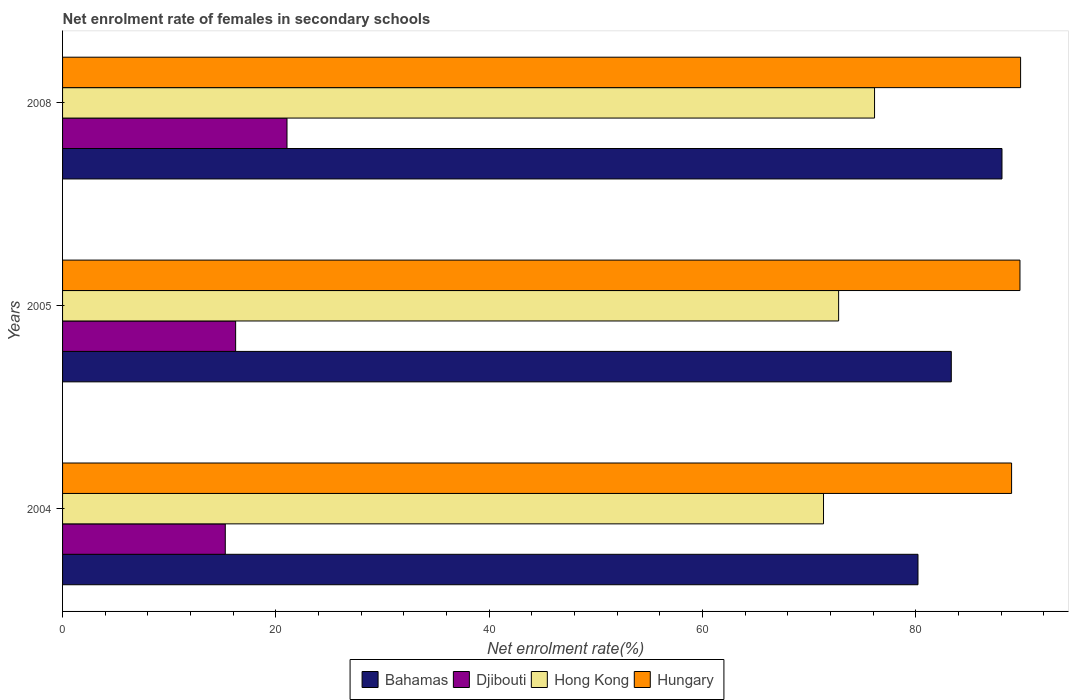How many different coloured bars are there?
Your answer should be very brief. 4. How many groups of bars are there?
Make the answer very short. 3. Are the number of bars on each tick of the Y-axis equal?
Keep it short and to the point. Yes. How many bars are there on the 1st tick from the bottom?
Offer a very short reply. 4. What is the label of the 1st group of bars from the top?
Provide a short and direct response. 2008. What is the net enrolment rate of females in secondary schools in Hong Kong in 2008?
Provide a short and direct response. 76.13. Across all years, what is the maximum net enrolment rate of females in secondary schools in Bahamas?
Your answer should be compact. 88.08. Across all years, what is the minimum net enrolment rate of females in secondary schools in Djibouti?
Your response must be concise. 15.26. In which year was the net enrolment rate of females in secondary schools in Bahamas maximum?
Provide a succinct answer. 2008. In which year was the net enrolment rate of females in secondary schools in Hungary minimum?
Make the answer very short. 2004. What is the total net enrolment rate of females in secondary schools in Bahamas in the graph?
Keep it short and to the point. 251.6. What is the difference between the net enrolment rate of females in secondary schools in Bahamas in 2004 and that in 2005?
Your response must be concise. -3.12. What is the difference between the net enrolment rate of females in secondary schools in Bahamas in 2004 and the net enrolment rate of females in secondary schools in Hungary in 2005?
Make the answer very short. -9.56. What is the average net enrolment rate of females in secondary schools in Djibouti per year?
Provide a short and direct response. 17.51. In the year 2004, what is the difference between the net enrolment rate of females in secondary schools in Hungary and net enrolment rate of females in secondary schools in Hong Kong?
Provide a succinct answer. 17.63. In how many years, is the net enrolment rate of females in secondary schools in Bahamas greater than 20 %?
Provide a succinct answer. 3. What is the ratio of the net enrolment rate of females in secondary schools in Hong Kong in 2004 to that in 2008?
Ensure brevity in your answer.  0.94. Is the net enrolment rate of females in secondary schools in Djibouti in 2004 less than that in 2008?
Make the answer very short. Yes. Is the difference between the net enrolment rate of females in secondary schools in Hungary in 2004 and 2005 greater than the difference between the net enrolment rate of females in secondary schools in Hong Kong in 2004 and 2005?
Your answer should be compact. Yes. What is the difference between the highest and the second highest net enrolment rate of females in secondary schools in Hungary?
Ensure brevity in your answer.  0.06. What is the difference between the highest and the lowest net enrolment rate of females in secondary schools in Hungary?
Offer a terse response. 0.84. In how many years, is the net enrolment rate of females in secondary schools in Bahamas greater than the average net enrolment rate of females in secondary schools in Bahamas taken over all years?
Ensure brevity in your answer.  1. Is it the case that in every year, the sum of the net enrolment rate of females in secondary schools in Hungary and net enrolment rate of females in secondary schools in Hong Kong is greater than the sum of net enrolment rate of females in secondary schools in Djibouti and net enrolment rate of females in secondary schools in Bahamas?
Make the answer very short. Yes. What does the 4th bar from the top in 2008 represents?
Ensure brevity in your answer.  Bahamas. What does the 3rd bar from the bottom in 2008 represents?
Make the answer very short. Hong Kong. Are all the bars in the graph horizontal?
Your response must be concise. Yes. How many years are there in the graph?
Give a very brief answer. 3. Are the values on the major ticks of X-axis written in scientific E-notation?
Your response must be concise. No. Does the graph contain grids?
Keep it short and to the point. No. How are the legend labels stacked?
Provide a succinct answer. Horizontal. What is the title of the graph?
Make the answer very short. Net enrolment rate of females in secondary schools. What is the label or title of the X-axis?
Offer a terse response. Net enrolment rate(%). What is the label or title of the Y-axis?
Provide a succinct answer. Years. What is the Net enrolment rate(%) in Bahamas in 2004?
Your answer should be compact. 80.2. What is the Net enrolment rate(%) in Djibouti in 2004?
Ensure brevity in your answer.  15.26. What is the Net enrolment rate(%) in Hong Kong in 2004?
Your answer should be compact. 71.35. What is the Net enrolment rate(%) in Hungary in 2004?
Make the answer very short. 88.98. What is the Net enrolment rate(%) in Bahamas in 2005?
Your answer should be very brief. 83.32. What is the Net enrolment rate(%) in Djibouti in 2005?
Offer a terse response. 16.23. What is the Net enrolment rate(%) in Hong Kong in 2005?
Provide a succinct answer. 72.76. What is the Net enrolment rate(%) in Hungary in 2005?
Provide a short and direct response. 89.76. What is the Net enrolment rate(%) in Bahamas in 2008?
Provide a succinct answer. 88.08. What is the Net enrolment rate(%) in Djibouti in 2008?
Provide a succinct answer. 21.04. What is the Net enrolment rate(%) of Hong Kong in 2008?
Your answer should be very brief. 76.13. What is the Net enrolment rate(%) in Hungary in 2008?
Give a very brief answer. 89.82. Across all years, what is the maximum Net enrolment rate(%) in Bahamas?
Make the answer very short. 88.08. Across all years, what is the maximum Net enrolment rate(%) in Djibouti?
Ensure brevity in your answer.  21.04. Across all years, what is the maximum Net enrolment rate(%) of Hong Kong?
Ensure brevity in your answer.  76.13. Across all years, what is the maximum Net enrolment rate(%) in Hungary?
Offer a very short reply. 89.82. Across all years, what is the minimum Net enrolment rate(%) in Bahamas?
Provide a short and direct response. 80.2. Across all years, what is the minimum Net enrolment rate(%) in Djibouti?
Offer a terse response. 15.26. Across all years, what is the minimum Net enrolment rate(%) of Hong Kong?
Offer a very short reply. 71.35. Across all years, what is the minimum Net enrolment rate(%) in Hungary?
Provide a succinct answer. 88.98. What is the total Net enrolment rate(%) in Bahamas in the graph?
Ensure brevity in your answer.  251.6. What is the total Net enrolment rate(%) in Djibouti in the graph?
Give a very brief answer. 52.53. What is the total Net enrolment rate(%) in Hong Kong in the graph?
Provide a succinct answer. 220.24. What is the total Net enrolment rate(%) in Hungary in the graph?
Ensure brevity in your answer.  268.56. What is the difference between the Net enrolment rate(%) in Bahamas in 2004 and that in 2005?
Provide a succinct answer. -3.12. What is the difference between the Net enrolment rate(%) of Djibouti in 2004 and that in 2005?
Ensure brevity in your answer.  -0.97. What is the difference between the Net enrolment rate(%) of Hong Kong in 2004 and that in 2005?
Ensure brevity in your answer.  -1.42. What is the difference between the Net enrolment rate(%) in Hungary in 2004 and that in 2005?
Offer a very short reply. -0.78. What is the difference between the Net enrolment rate(%) in Bahamas in 2004 and that in 2008?
Provide a succinct answer. -7.88. What is the difference between the Net enrolment rate(%) of Djibouti in 2004 and that in 2008?
Provide a succinct answer. -5.79. What is the difference between the Net enrolment rate(%) in Hong Kong in 2004 and that in 2008?
Provide a succinct answer. -4.78. What is the difference between the Net enrolment rate(%) in Hungary in 2004 and that in 2008?
Provide a short and direct response. -0.84. What is the difference between the Net enrolment rate(%) of Bahamas in 2005 and that in 2008?
Your response must be concise. -4.75. What is the difference between the Net enrolment rate(%) in Djibouti in 2005 and that in 2008?
Your response must be concise. -4.82. What is the difference between the Net enrolment rate(%) of Hong Kong in 2005 and that in 2008?
Keep it short and to the point. -3.37. What is the difference between the Net enrolment rate(%) of Hungary in 2005 and that in 2008?
Provide a short and direct response. -0.06. What is the difference between the Net enrolment rate(%) in Bahamas in 2004 and the Net enrolment rate(%) in Djibouti in 2005?
Offer a terse response. 63.98. What is the difference between the Net enrolment rate(%) in Bahamas in 2004 and the Net enrolment rate(%) in Hong Kong in 2005?
Your response must be concise. 7.44. What is the difference between the Net enrolment rate(%) in Bahamas in 2004 and the Net enrolment rate(%) in Hungary in 2005?
Your response must be concise. -9.56. What is the difference between the Net enrolment rate(%) in Djibouti in 2004 and the Net enrolment rate(%) in Hong Kong in 2005?
Make the answer very short. -57.51. What is the difference between the Net enrolment rate(%) of Djibouti in 2004 and the Net enrolment rate(%) of Hungary in 2005?
Provide a short and direct response. -74.51. What is the difference between the Net enrolment rate(%) of Hong Kong in 2004 and the Net enrolment rate(%) of Hungary in 2005?
Give a very brief answer. -18.42. What is the difference between the Net enrolment rate(%) of Bahamas in 2004 and the Net enrolment rate(%) of Djibouti in 2008?
Offer a very short reply. 59.16. What is the difference between the Net enrolment rate(%) of Bahamas in 2004 and the Net enrolment rate(%) of Hong Kong in 2008?
Provide a succinct answer. 4.07. What is the difference between the Net enrolment rate(%) in Bahamas in 2004 and the Net enrolment rate(%) in Hungary in 2008?
Ensure brevity in your answer.  -9.62. What is the difference between the Net enrolment rate(%) of Djibouti in 2004 and the Net enrolment rate(%) of Hong Kong in 2008?
Your answer should be very brief. -60.87. What is the difference between the Net enrolment rate(%) of Djibouti in 2004 and the Net enrolment rate(%) of Hungary in 2008?
Give a very brief answer. -74.57. What is the difference between the Net enrolment rate(%) of Hong Kong in 2004 and the Net enrolment rate(%) of Hungary in 2008?
Give a very brief answer. -18.48. What is the difference between the Net enrolment rate(%) in Bahamas in 2005 and the Net enrolment rate(%) in Djibouti in 2008?
Provide a short and direct response. 62.28. What is the difference between the Net enrolment rate(%) of Bahamas in 2005 and the Net enrolment rate(%) of Hong Kong in 2008?
Your answer should be compact. 7.2. What is the difference between the Net enrolment rate(%) in Bahamas in 2005 and the Net enrolment rate(%) in Hungary in 2008?
Ensure brevity in your answer.  -6.5. What is the difference between the Net enrolment rate(%) in Djibouti in 2005 and the Net enrolment rate(%) in Hong Kong in 2008?
Give a very brief answer. -59.9. What is the difference between the Net enrolment rate(%) of Djibouti in 2005 and the Net enrolment rate(%) of Hungary in 2008?
Give a very brief answer. -73.6. What is the difference between the Net enrolment rate(%) of Hong Kong in 2005 and the Net enrolment rate(%) of Hungary in 2008?
Your answer should be very brief. -17.06. What is the average Net enrolment rate(%) in Bahamas per year?
Provide a succinct answer. 83.87. What is the average Net enrolment rate(%) in Djibouti per year?
Keep it short and to the point. 17.51. What is the average Net enrolment rate(%) of Hong Kong per year?
Make the answer very short. 73.41. What is the average Net enrolment rate(%) of Hungary per year?
Your answer should be very brief. 89.52. In the year 2004, what is the difference between the Net enrolment rate(%) in Bahamas and Net enrolment rate(%) in Djibouti?
Provide a short and direct response. 64.95. In the year 2004, what is the difference between the Net enrolment rate(%) of Bahamas and Net enrolment rate(%) of Hong Kong?
Provide a short and direct response. 8.86. In the year 2004, what is the difference between the Net enrolment rate(%) of Bahamas and Net enrolment rate(%) of Hungary?
Make the answer very short. -8.78. In the year 2004, what is the difference between the Net enrolment rate(%) of Djibouti and Net enrolment rate(%) of Hong Kong?
Your response must be concise. -56.09. In the year 2004, what is the difference between the Net enrolment rate(%) in Djibouti and Net enrolment rate(%) in Hungary?
Your answer should be very brief. -73.72. In the year 2004, what is the difference between the Net enrolment rate(%) in Hong Kong and Net enrolment rate(%) in Hungary?
Ensure brevity in your answer.  -17.63. In the year 2005, what is the difference between the Net enrolment rate(%) in Bahamas and Net enrolment rate(%) in Djibouti?
Your answer should be very brief. 67.1. In the year 2005, what is the difference between the Net enrolment rate(%) of Bahamas and Net enrolment rate(%) of Hong Kong?
Give a very brief answer. 10.56. In the year 2005, what is the difference between the Net enrolment rate(%) in Bahamas and Net enrolment rate(%) in Hungary?
Offer a terse response. -6.44. In the year 2005, what is the difference between the Net enrolment rate(%) of Djibouti and Net enrolment rate(%) of Hong Kong?
Keep it short and to the point. -56.53. In the year 2005, what is the difference between the Net enrolment rate(%) of Djibouti and Net enrolment rate(%) of Hungary?
Ensure brevity in your answer.  -73.54. In the year 2005, what is the difference between the Net enrolment rate(%) of Hong Kong and Net enrolment rate(%) of Hungary?
Offer a terse response. -17. In the year 2008, what is the difference between the Net enrolment rate(%) in Bahamas and Net enrolment rate(%) in Djibouti?
Keep it short and to the point. 67.04. In the year 2008, what is the difference between the Net enrolment rate(%) in Bahamas and Net enrolment rate(%) in Hong Kong?
Provide a succinct answer. 11.95. In the year 2008, what is the difference between the Net enrolment rate(%) in Bahamas and Net enrolment rate(%) in Hungary?
Make the answer very short. -1.74. In the year 2008, what is the difference between the Net enrolment rate(%) in Djibouti and Net enrolment rate(%) in Hong Kong?
Offer a very short reply. -55.09. In the year 2008, what is the difference between the Net enrolment rate(%) of Djibouti and Net enrolment rate(%) of Hungary?
Keep it short and to the point. -68.78. In the year 2008, what is the difference between the Net enrolment rate(%) in Hong Kong and Net enrolment rate(%) in Hungary?
Make the answer very short. -13.69. What is the ratio of the Net enrolment rate(%) in Bahamas in 2004 to that in 2005?
Keep it short and to the point. 0.96. What is the ratio of the Net enrolment rate(%) of Djibouti in 2004 to that in 2005?
Your answer should be very brief. 0.94. What is the ratio of the Net enrolment rate(%) in Hong Kong in 2004 to that in 2005?
Ensure brevity in your answer.  0.98. What is the ratio of the Net enrolment rate(%) in Hungary in 2004 to that in 2005?
Offer a terse response. 0.99. What is the ratio of the Net enrolment rate(%) of Bahamas in 2004 to that in 2008?
Give a very brief answer. 0.91. What is the ratio of the Net enrolment rate(%) of Djibouti in 2004 to that in 2008?
Offer a very short reply. 0.72. What is the ratio of the Net enrolment rate(%) of Hong Kong in 2004 to that in 2008?
Give a very brief answer. 0.94. What is the ratio of the Net enrolment rate(%) of Hungary in 2004 to that in 2008?
Keep it short and to the point. 0.99. What is the ratio of the Net enrolment rate(%) of Bahamas in 2005 to that in 2008?
Keep it short and to the point. 0.95. What is the ratio of the Net enrolment rate(%) of Djibouti in 2005 to that in 2008?
Make the answer very short. 0.77. What is the ratio of the Net enrolment rate(%) of Hong Kong in 2005 to that in 2008?
Your answer should be very brief. 0.96. What is the ratio of the Net enrolment rate(%) in Hungary in 2005 to that in 2008?
Your answer should be very brief. 1. What is the difference between the highest and the second highest Net enrolment rate(%) of Bahamas?
Your answer should be compact. 4.75. What is the difference between the highest and the second highest Net enrolment rate(%) in Djibouti?
Keep it short and to the point. 4.82. What is the difference between the highest and the second highest Net enrolment rate(%) of Hong Kong?
Your answer should be very brief. 3.37. What is the difference between the highest and the second highest Net enrolment rate(%) in Hungary?
Make the answer very short. 0.06. What is the difference between the highest and the lowest Net enrolment rate(%) of Bahamas?
Ensure brevity in your answer.  7.88. What is the difference between the highest and the lowest Net enrolment rate(%) of Djibouti?
Offer a terse response. 5.79. What is the difference between the highest and the lowest Net enrolment rate(%) of Hong Kong?
Keep it short and to the point. 4.78. What is the difference between the highest and the lowest Net enrolment rate(%) in Hungary?
Your answer should be compact. 0.84. 